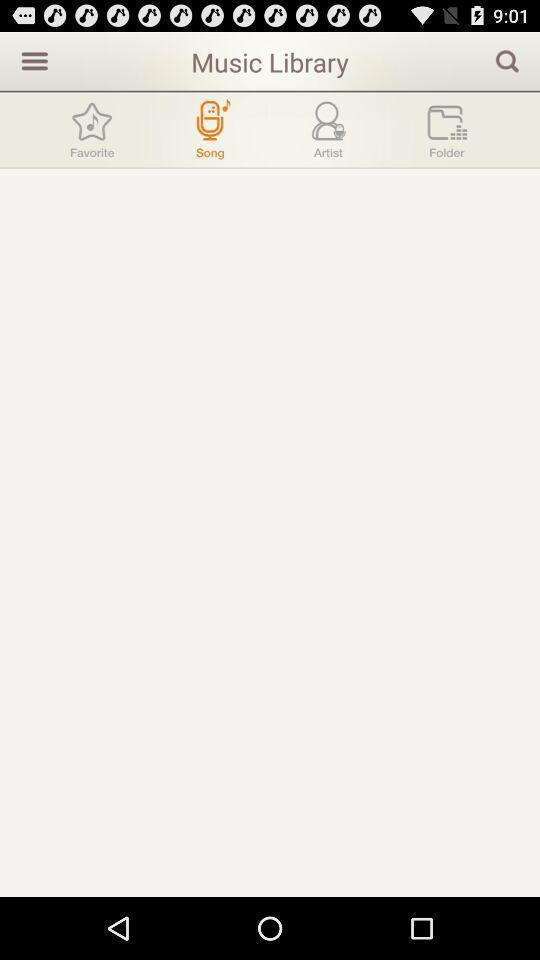Give me a summary of this screen capture. Page showing search bar to find songs. 